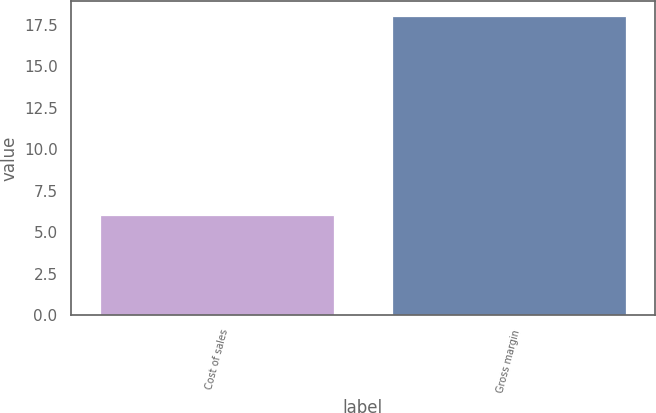Convert chart. <chart><loc_0><loc_0><loc_500><loc_500><bar_chart><fcel>Cost of sales<fcel>Gross margin<nl><fcel>6<fcel>18<nl></chart> 